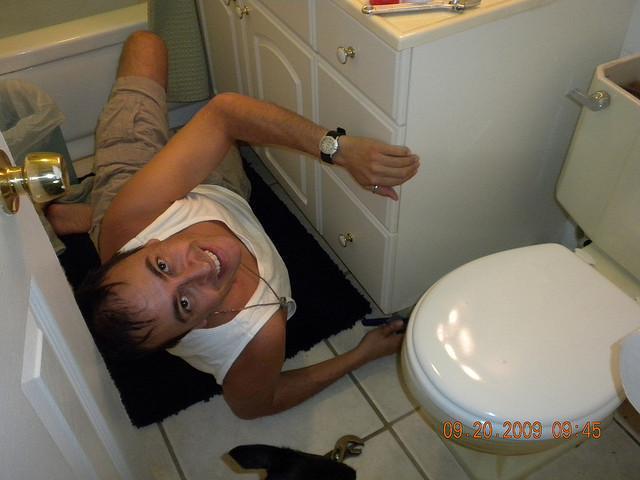How many toilets are there?
Give a very brief answer. 1. 